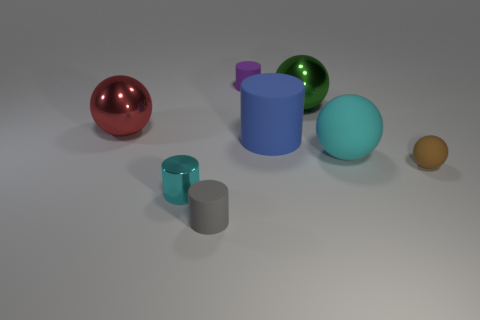Are there more metal cylinders right of the brown rubber thing than big green objects behind the red metal sphere?
Provide a short and direct response. No. There is a cyan cylinder on the left side of the tiny brown matte object; what is its material?
Offer a very short reply. Metal. There is a small gray matte thing; is its shape the same as the large thing on the left side of the small gray thing?
Provide a succinct answer. No. There is a cyan object left of the large metal sphere that is on the right side of the cyan metal object; how many cyan cylinders are behind it?
Offer a very short reply. 0. The tiny metallic object that is the same shape as the purple matte thing is what color?
Provide a short and direct response. Cyan. Is there anything else that has the same shape as the cyan metal thing?
Your response must be concise. Yes. How many cylinders are tiny rubber things or green metallic things?
Your answer should be very brief. 2. What shape is the big green object?
Your answer should be very brief. Sphere. Are there any large green spheres in front of the big green sphere?
Give a very brief answer. No. Is the gray object made of the same material as the small cylinder behind the red shiny thing?
Your response must be concise. Yes. 